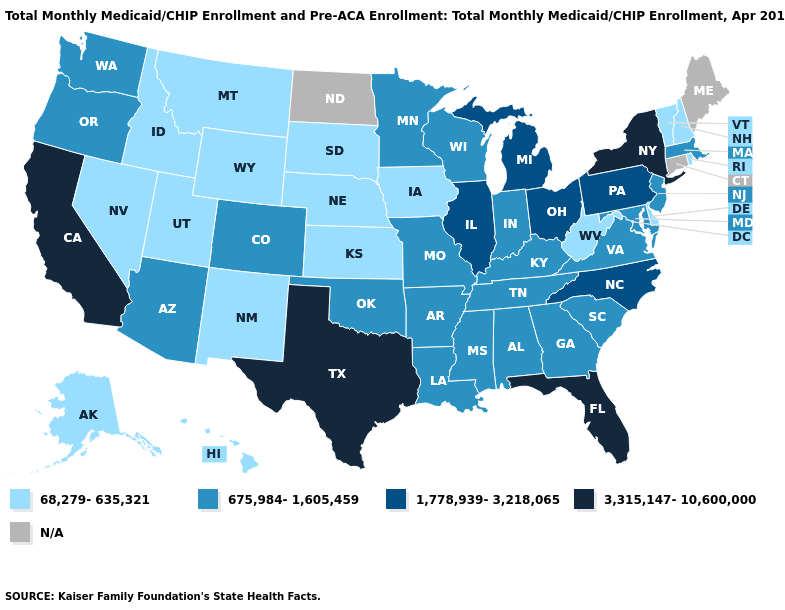What is the highest value in states that border New Jersey?
Concise answer only. 3,315,147-10,600,000. Does Idaho have the lowest value in the West?
Concise answer only. Yes. What is the lowest value in the Northeast?
Answer briefly. 68,279-635,321. Name the states that have a value in the range 68,279-635,321?
Keep it brief. Alaska, Delaware, Hawaii, Idaho, Iowa, Kansas, Montana, Nebraska, Nevada, New Hampshire, New Mexico, Rhode Island, South Dakota, Utah, Vermont, West Virginia, Wyoming. Does the first symbol in the legend represent the smallest category?
Quick response, please. Yes. Which states have the lowest value in the West?
Quick response, please. Alaska, Hawaii, Idaho, Montana, Nevada, New Mexico, Utah, Wyoming. Name the states that have a value in the range 675,984-1,605,459?
Write a very short answer. Alabama, Arizona, Arkansas, Colorado, Georgia, Indiana, Kentucky, Louisiana, Maryland, Massachusetts, Minnesota, Mississippi, Missouri, New Jersey, Oklahoma, Oregon, South Carolina, Tennessee, Virginia, Washington, Wisconsin. What is the lowest value in states that border New York?
Give a very brief answer. 68,279-635,321. Name the states that have a value in the range N/A?
Keep it brief. Connecticut, Maine, North Dakota. What is the highest value in the West ?
Answer briefly. 3,315,147-10,600,000. What is the value of Oregon?
Be succinct. 675,984-1,605,459. Does New York have the highest value in the USA?
Concise answer only. Yes. Does New Mexico have the lowest value in the West?
Write a very short answer. Yes. What is the value of Pennsylvania?
Concise answer only. 1,778,939-3,218,065. 